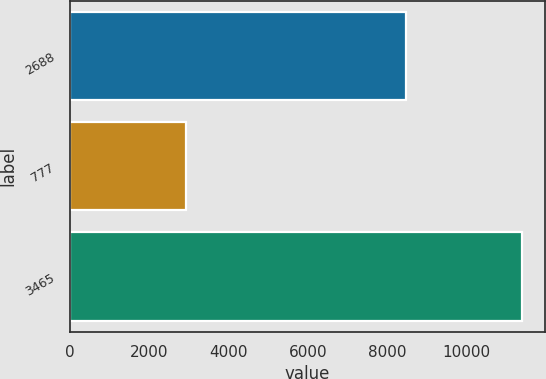Convert chart. <chart><loc_0><loc_0><loc_500><loc_500><bar_chart><fcel>2688<fcel>777<fcel>3465<nl><fcel>8485<fcel>2924<fcel>11409<nl></chart> 